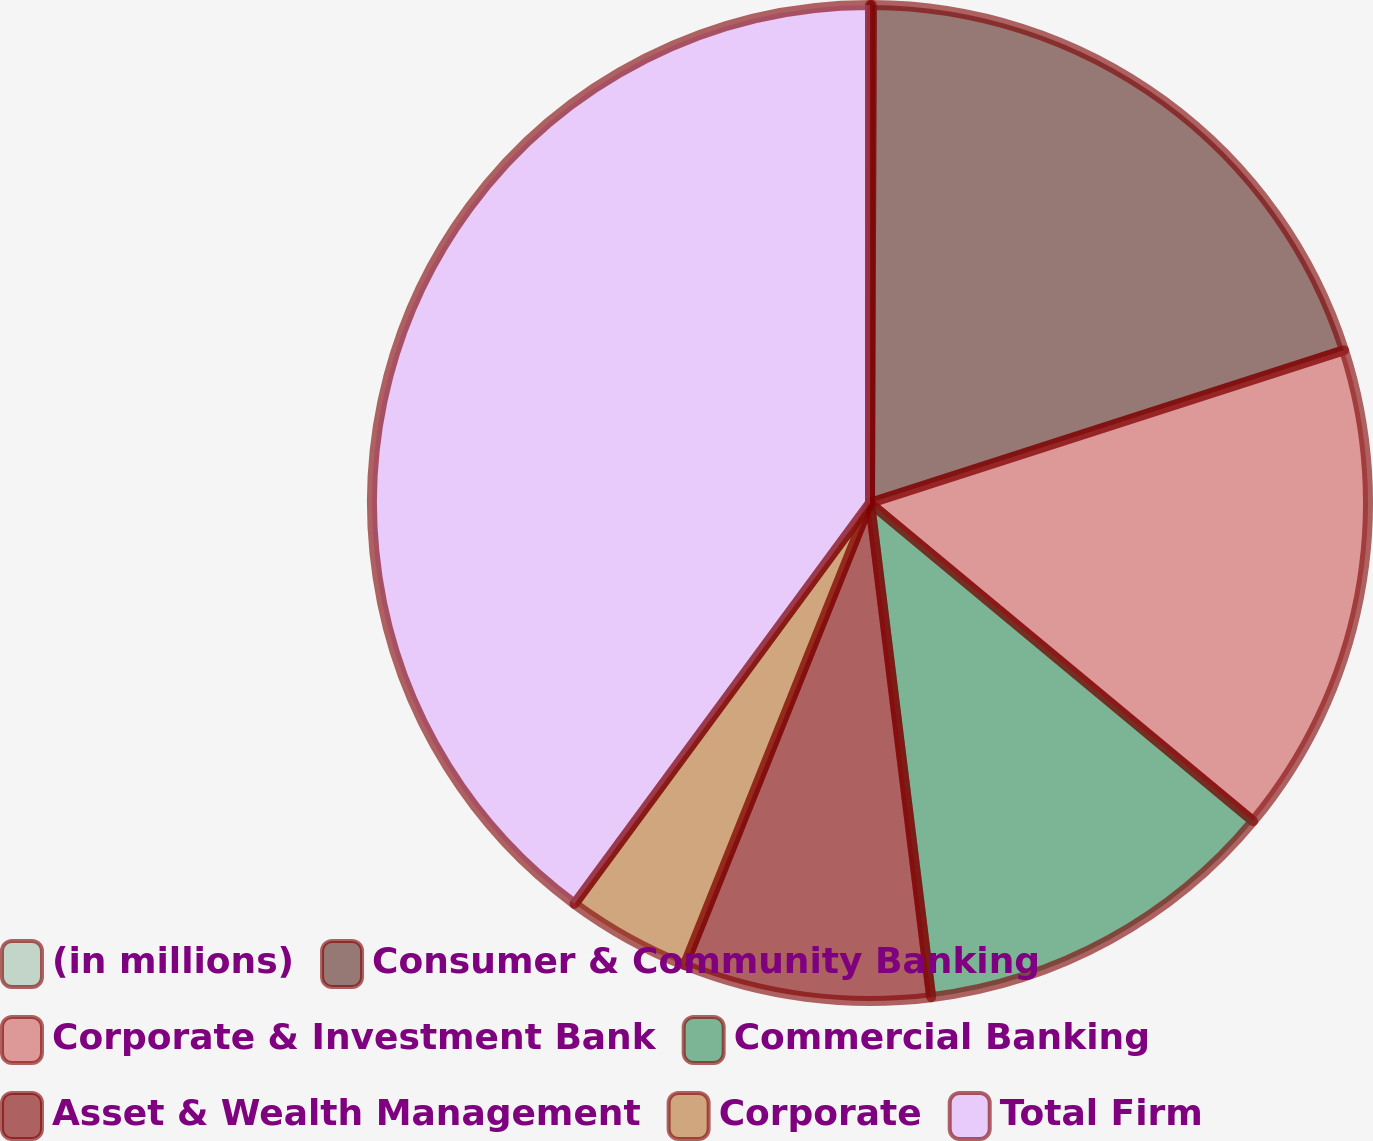Convert chart. <chart><loc_0><loc_0><loc_500><loc_500><pie_chart><fcel>(in millions)<fcel>Consumer & Community Banking<fcel>Corporate & Investment Bank<fcel>Commercial Banking<fcel>Asset & Wealth Management<fcel>Corporate<fcel>Total Firm<nl><fcel>0.06%<fcel>19.98%<fcel>15.99%<fcel>12.01%<fcel>8.03%<fcel>4.04%<fcel>39.89%<nl></chart> 